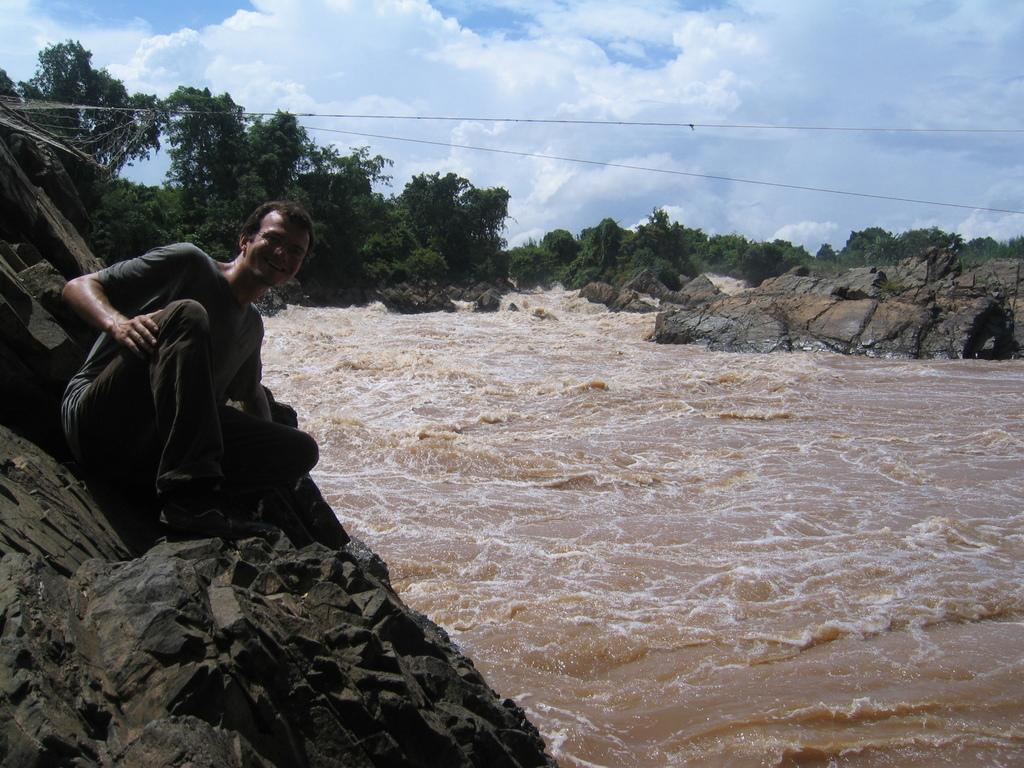Who is on the left side of the image? There is a man on the left side of the image. What is the man standing on? The man is on rocks. What can be seen in the center of the image? There is water in the center of the image. What type of vegetation is visible in the background of the image? There are trees in the background of the image. What type of train can be seen in the image? There is no train present in the image. What is the man's reason for being in the image? The image does not provide information about the man's reason for being there. 